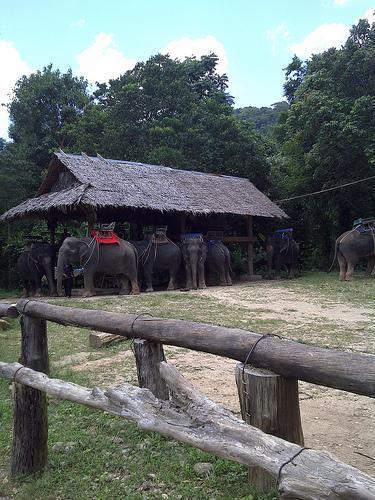How many red saddles are in the image?
Give a very brief answer. 1. 